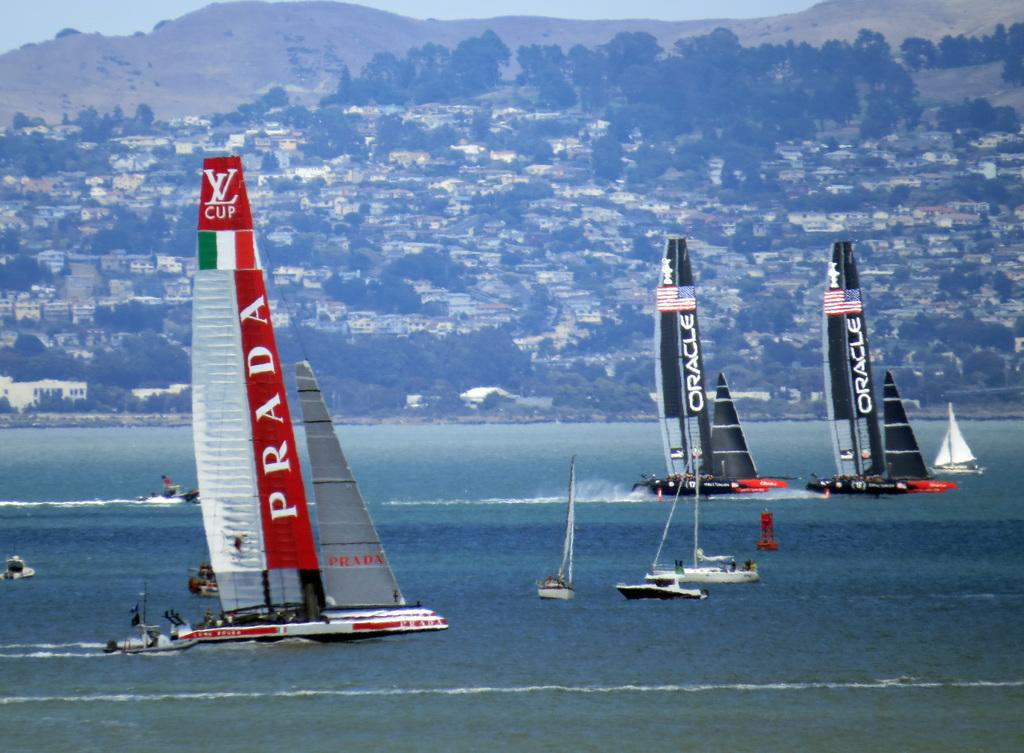What is happening on the water in the image? There are boats sailing on the water in the image. What can be seen in the background of the image? Trees, houses, buildings, hills, and the sky are visible in the background of the image. Can you describe the natural elements in the background? The background includes trees and hills. What type of structures can be seen in the background? Houses and buildings are visible in the background. How many cars are parked near the steel office building in the image? There are no cars or steel office buildings present in the image. 